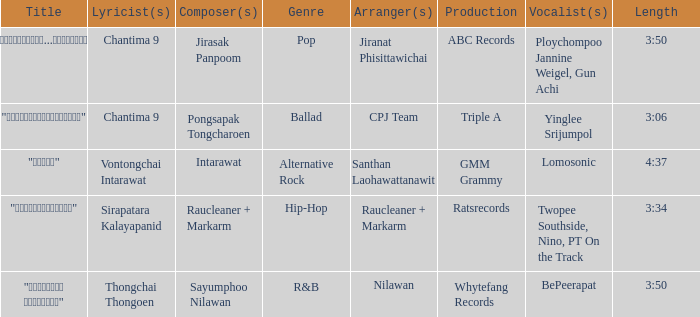Who arranged the song with lyrics written by sirapatara kalayapanid? Raucleaner + Markarm. Help me parse the entirety of this table. {'header': ['Title', 'Lyricist(s)', 'Composer(s)', 'Genre', 'Arranger(s)', 'Production', 'Vocalist(s)', 'Length'], 'rows': [['"เรายังรักกัน...ไม่ใช่เหรอ"', 'Chantima 9', 'Jirasak Panpoom', 'Pop', 'Jiranat Phisittawichai', 'ABC Records', 'Ploychompoo Jannine Weigel, Gun Achi', '3:50'], ['"นางฟ้าตาชั้นเดียว"', 'Chantima 9', 'Pongsapak Tongcharoen', 'Ballad', 'CPJ Team', 'Triple A', 'Yinglee Srijumpol', '3:06'], ['"ขอโทษ"', 'Vontongchai Intarawat', 'Intarawat', 'Alternative Rock', 'Santhan Laohawattanawit', 'GMM Grammy', 'Lomosonic', '4:37'], ['"แค่อยากให้รู้"', 'Sirapatara Kalayapanid', 'Raucleaner + Markarm', 'Hip-Hop', 'Raucleaner + Markarm', 'Ratsrecords', 'Twopee Southside, Nino, PT On the Track', '3:34'], ['"เลือกลืม เลือกจำ"', 'Thongchai Thongoen', 'Sayumphoo Nilawan', 'R&B', 'Nilawan', 'Whytefang Records', 'BePeerapat', '3:50']]} 